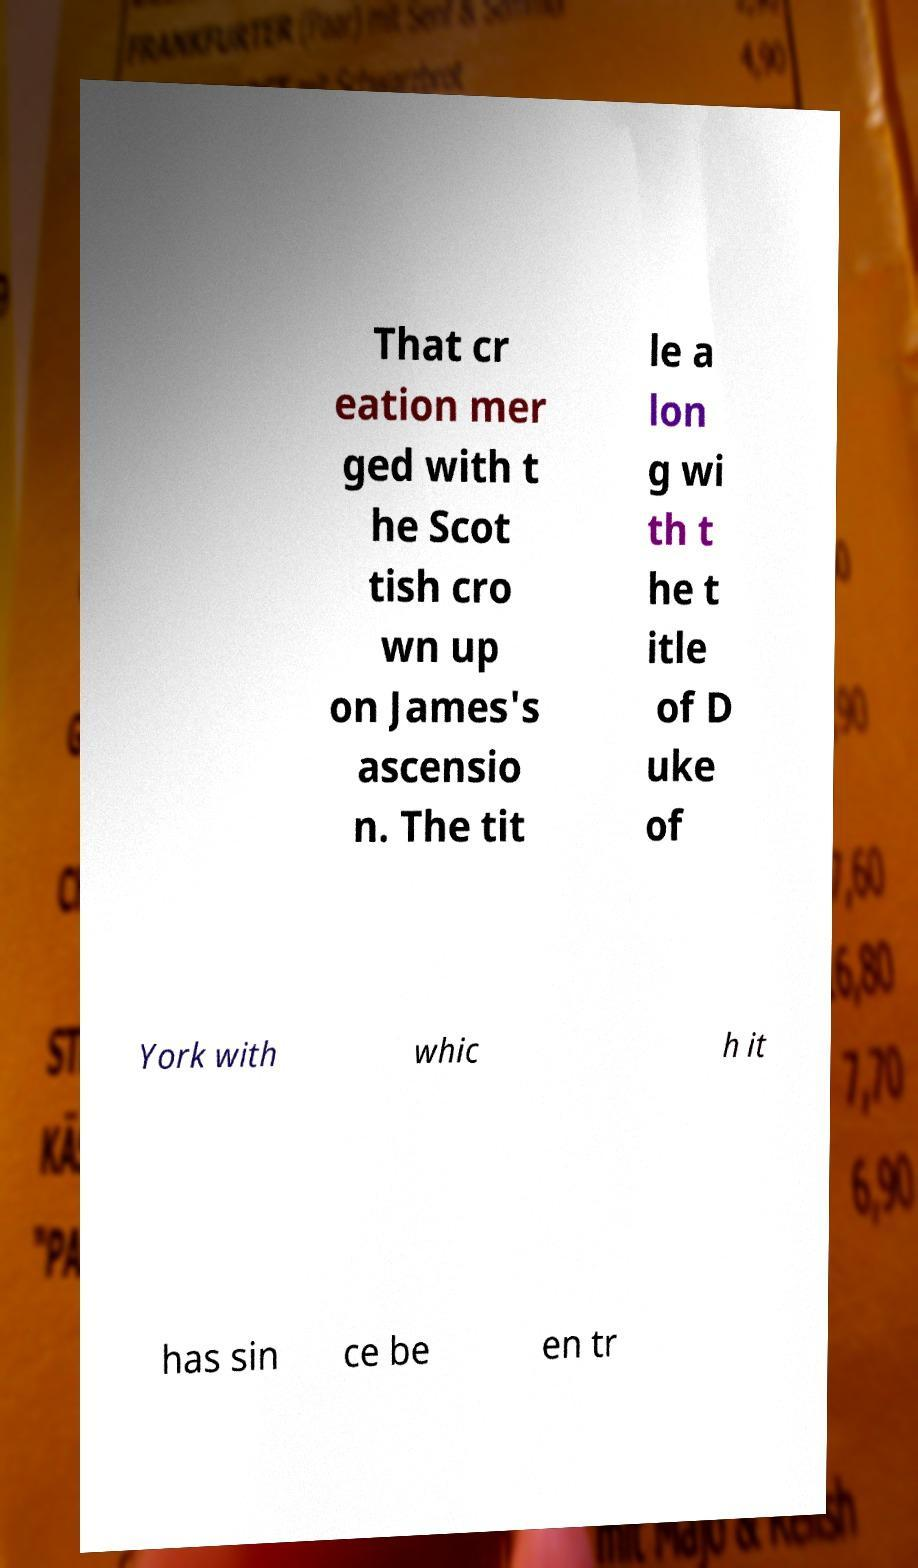Can you read and provide the text displayed in the image?This photo seems to have some interesting text. Can you extract and type it out for me? That cr eation mer ged with t he Scot tish cro wn up on James's ascensio n. The tit le a lon g wi th t he t itle of D uke of York with whic h it has sin ce be en tr 